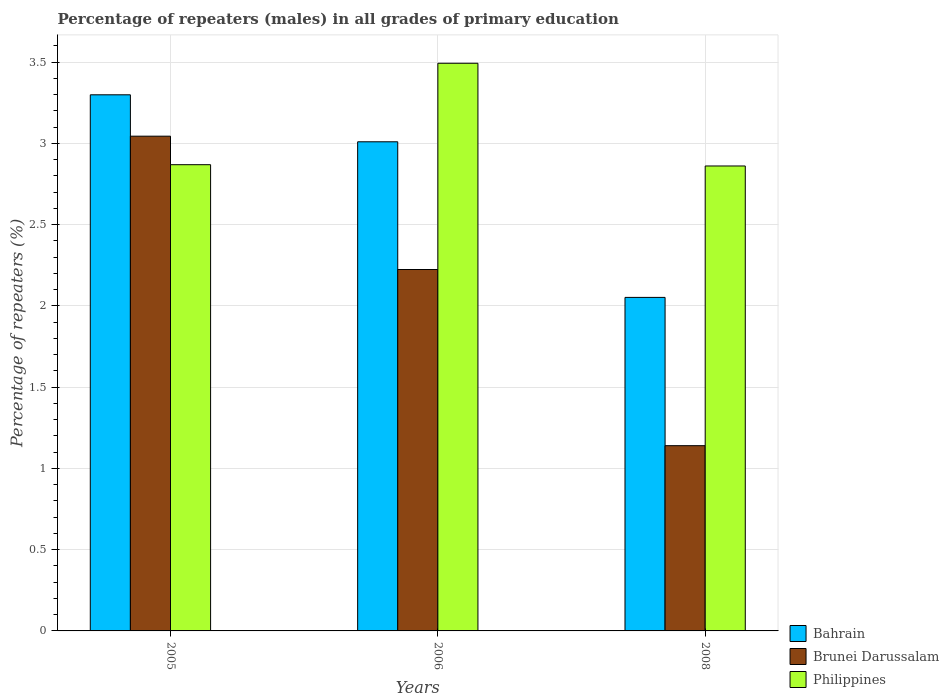How many different coloured bars are there?
Keep it short and to the point. 3. Are the number of bars per tick equal to the number of legend labels?
Your answer should be compact. Yes. Are the number of bars on each tick of the X-axis equal?
Give a very brief answer. Yes. How many bars are there on the 2nd tick from the left?
Keep it short and to the point. 3. How many bars are there on the 3rd tick from the right?
Offer a very short reply. 3. What is the percentage of repeaters (males) in Bahrain in 2006?
Ensure brevity in your answer.  3.01. Across all years, what is the maximum percentage of repeaters (males) in Philippines?
Your answer should be compact. 3.49. Across all years, what is the minimum percentage of repeaters (males) in Brunei Darussalam?
Ensure brevity in your answer.  1.14. In which year was the percentage of repeaters (males) in Brunei Darussalam maximum?
Keep it short and to the point. 2005. In which year was the percentage of repeaters (males) in Bahrain minimum?
Provide a short and direct response. 2008. What is the total percentage of repeaters (males) in Philippines in the graph?
Offer a very short reply. 9.22. What is the difference between the percentage of repeaters (males) in Philippines in 2005 and that in 2006?
Your response must be concise. -0.62. What is the difference between the percentage of repeaters (males) in Philippines in 2008 and the percentage of repeaters (males) in Brunei Darussalam in 2006?
Provide a succinct answer. 0.64. What is the average percentage of repeaters (males) in Bahrain per year?
Your answer should be very brief. 2.79. In the year 2008, what is the difference between the percentage of repeaters (males) in Philippines and percentage of repeaters (males) in Bahrain?
Offer a terse response. 0.81. What is the ratio of the percentage of repeaters (males) in Philippines in 2006 to that in 2008?
Your answer should be very brief. 1.22. What is the difference between the highest and the second highest percentage of repeaters (males) in Bahrain?
Provide a succinct answer. 0.29. What is the difference between the highest and the lowest percentage of repeaters (males) in Bahrain?
Give a very brief answer. 1.25. In how many years, is the percentage of repeaters (males) in Bahrain greater than the average percentage of repeaters (males) in Bahrain taken over all years?
Offer a terse response. 2. Is the sum of the percentage of repeaters (males) in Philippines in 2005 and 2006 greater than the maximum percentage of repeaters (males) in Bahrain across all years?
Provide a short and direct response. Yes. What does the 2nd bar from the left in 2006 represents?
Give a very brief answer. Brunei Darussalam. Is it the case that in every year, the sum of the percentage of repeaters (males) in Philippines and percentage of repeaters (males) in Brunei Darussalam is greater than the percentage of repeaters (males) in Bahrain?
Offer a terse response. Yes. How many bars are there?
Keep it short and to the point. 9. Are all the bars in the graph horizontal?
Provide a succinct answer. No. How many years are there in the graph?
Provide a succinct answer. 3. What is the difference between two consecutive major ticks on the Y-axis?
Offer a very short reply. 0.5. Does the graph contain any zero values?
Make the answer very short. No. What is the title of the graph?
Give a very brief answer. Percentage of repeaters (males) in all grades of primary education. What is the label or title of the Y-axis?
Ensure brevity in your answer.  Percentage of repeaters (%). What is the Percentage of repeaters (%) of Bahrain in 2005?
Your response must be concise. 3.3. What is the Percentage of repeaters (%) of Brunei Darussalam in 2005?
Provide a succinct answer. 3.04. What is the Percentage of repeaters (%) in Philippines in 2005?
Ensure brevity in your answer.  2.87. What is the Percentage of repeaters (%) of Bahrain in 2006?
Provide a short and direct response. 3.01. What is the Percentage of repeaters (%) in Brunei Darussalam in 2006?
Your response must be concise. 2.22. What is the Percentage of repeaters (%) of Philippines in 2006?
Give a very brief answer. 3.49. What is the Percentage of repeaters (%) in Bahrain in 2008?
Your answer should be very brief. 2.05. What is the Percentage of repeaters (%) in Brunei Darussalam in 2008?
Provide a succinct answer. 1.14. What is the Percentage of repeaters (%) of Philippines in 2008?
Offer a very short reply. 2.86. Across all years, what is the maximum Percentage of repeaters (%) in Bahrain?
Provide a succinct answer. 3.3. Across all years, what is the maximum Percentage of repeaters (%) in Brunei Darussalam?
Ensure brevity in your answer.  3.04. Across all years, what is the maximum Percentage of repeaters (%) of Philippines?
Provide a succinct answer. 3.49. Across all years, what is the minimum Percentage of repeaters (%) of Bahrain?
Offer a very short reply. 2.05. Across all years, what is the minimum Percentage of repeaters (%) of Brunei Darussalam?
Give a very brief answer. 1.14. Across all years, what is the minimum Percentage of repeaters (%) of Philippines?
Your answer should be very brief. 2.86. What is the total Percentage of repeaters (%) in Bahrain in the graph?
Keep it short and to the point. 8.36. What is the total Percentage of repeaters (%) of Brunei Darussalam in the graph?
Provide a succinct answer. 6.41. What is the total Percentage of repeaters (%) of Philippines in the graph?
Provide a short and direct response. 9.22. What is the difference between the Percentage of repeaters (%) in Bahrain in 2005 and that in 2006?
Keep it short and to the point. 0.29. What is the difference between the Percentage of repeaters (%) in Brunei Darussalam in 2005 and that in 2006?
Offer a terse response. 0.82. What is the difference between the Percentage of repeaters (%) of Philippines in 2005 and that in 2006?
Your response must be concise. -0.62. What is the difference between the Percentage of repeaters (%) in Bahrain in 2005 and that in 2008?
Offer a terse response. 1.25. What is the difference between the Percentage of repeaters (%) of Brunei Darussalam in 2005 and that in 2008?
Your response must be concise. 1.9. What is the difference between the Percentage of repeaters (%) in Philippines in 2005 and that in 2008?
Offer a very short reply. 0.01. What is the difference between the Percentage of repeaters (%) of Bahrain in 2006 and that in 2008?
Your answer should be very brief. 0.96. What is the difference between the Percentage of repeaters (%) of Brunei Darussalam in 2006 and that in 2008?
Keep it short and to the point. 1.08. What is the difference between the Percentage of repeaters (%) in Philippines in 2006 and that in 2008?
Provide a short and direct response. 0.63. What is the difference between the Percentage of repeaters (%) in Bahrain in 2005 and the Percentage of repeaters (%) in Brunei Darussalam in 2006?
Offer a terse response. 1.07. What is the difference between the Percentage of repeaters (%) of Bahrain in 2005 and the Percentage of repeaters (%) of Philippines in 2006?
Provide a short and direct response. -0.19. What is the difference between the Percentage of repeaters (%) of Brunei Darussalam in 2005 and the Percentage of repeaters (%) of Philippines in 2006?
Provide a succinct answer. -0.45. What is the difference between the Percentage of repeaters (%) in Bahrain in 2005 and the Percentage of repeaters (%) in Brunei Darussalam in 2008?
Give a very brief answer. 2.16. What is the difference between the Percentage of repeaters (%) in Bahrain in 2005 and the Percentage of repeaters (%) in Philippines in 2008?
Your answer should be very brief. 0.44. What is the difference between the Percentage of repeaters (%) in Brunei Darussalam in 2005 and the Percentage of repeaters (%) in Philippines in 2008?
Provide a short and direct response. 0.18. What is the difference between the Percentage of repeaters (%) of Bahrain in 2006 and the Percentage of repeaters (%) of Brunei Darussalam in 2008?
Offer a very short reply. 1.87. What is the difference between the Percentage of repeaters (%) of Bahrain in 2006 and the Percentage of repeaters (%) of Philippines in 2008?
Offer a very short reply. 0.15. What is the difference between the Percentage of repeaters (%) of Brunei Darussalam in 2006 and the Percentage of repeaters (%) of Philippines in 2008?
Provide a succinct answer. -0.64. What is the average Percentage of repeaters (%) of Bahrain per year?
Keep it short and to the point. 2.79. What is the average Percentage of repeaters (%) in Brunei Darussalam per year?
Keep it short and to the point. 2.14. What is the average Percentage of repeaters (%) in Philippines per year?
Give a very brief answer. 3.07. In the year 2005, what is the difference between the Percentage of repeaters (%) of Bahrain and Percentage of repeaters (%) of Brunei Darussalam?
Ensure brevity in your answer.  0.25. In the year 2005, what is the difference between the Percentage of repeaters (%) of Bahrain and Percentage of repeaters (%) of Philippines?
Keep it short and to the point. 0.43. In the year 2005, what is the difference between the Percentage of repeaters (%) of Brunei Darussalam and Percentage of repeaters (%) of Philippines?
Give a very brief answer. 0.18. In the year 2006, what is the difference between the Percentage of repeaters (%) of Bahrain and Percentage of repeaters (%) of Brunei Darussalam?
Make the answer very short. 0.79. In the year 2006, what is the difference between the Percentage of repeaters (%) in Bahrain and Percentage of repeaters (%) in Philippines?
Keep it short and to the point. -0.48. In the year 2006, what is the difference between the Percentage of repeaters (%) in Brunei Darussalam and Percentage of repeaters (%) in Philippines?
Your answer should be very brief. -1.27. In the year 2008, what is the difference between the Percentage of repeaters (%) of Bahrain and Percentage of repeaters (%) of Brunei Darussalam?
Provide a short and direct response. 0.91. In the year 2008, what is the difference between the Percentage of repeaters (%) in Bahrain and Percentage of repeaters (%) in Philippines?
Provide a succinct answer. -0.81. In the year 2008, what is the difference between the Percentage of repeaters (%) of Brunei Darussalam and Percentage of repeaters (%) of Philippines?
Make the answer very short. -1.72. What is the ratio of the Percentage of repeaters (%) in Bahrain in 2005 to that in 2006?
Keep it short and to the point. 1.1. What is the ratio of the Percentage of repeaters (%) in Brunei Darussalam in 2005 to that in 2006?
Make the answer very short. 1.37. What is the ratio of the Percentage of repeaters (%) of Philippines in 2005 to that in 2006?
Keep it short and to the point. 0.82. What is the ratio of the Percentage of repeaters (%) of Bahrain in 2005 to that in 2008?
Provide a succinct answer. 1.61. What is the ratio of the Percentage of repeaters (%) of Brunei Darussalam in 2005 to that in 2008?
Make the answer very short. 2.67. What is the ratio of the Percentage of repeaters (%) in Bahrain in 2006 to that in 2008?
Keep it short and to the point. 1.47. What is the ratio of the Percentage of repeaters (%) of Brunei Darussalam in 2006 to that in 2008?
Give a very brief answer. 1.95. What is the ratio of the Percentage of repeaters (%) in Philippines in 2006 to that in 2008?
Offer a terse response. 1.22. What is the difference between the highest and the second highest Percentage of repeaters (%) in Bahrain?
Offer a very short reply. 0.29. What is the difference between the highest and the second highest Percentage of repeaters (%) of Brunei Darussalam?
Ensure brevity in your answer.  0.82. What is the difference between the highest and the second highest Percentage of repeaters (%) of Philippines?
Keep it short and to the point. 0.62. What is the difference between the highest and the lowest Percentage of repeaters (%) in Bahrain?
Your answer should be very brief. 1.25. What is the difference between the highest and the lowest Percentage of repeaters (%) in Brunei Darussalam?
Provide a short and direct response. 1.9. What is the difference between the highest and the lowest Percentage of repeaters (%) in Philippines?
Make the answer very short. 0.63. 